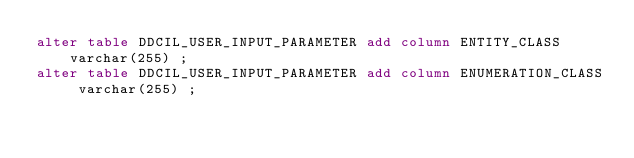Convert code to text. <code><loc_0><loc_0><loc_500><loc_500><_SQL_>alter table DDCIL_USER_INPUT_PARAMETER add column ENTITY_CLASS varchar(255) ;
alter table DDCIL_USER_INPUT_PARAMETER add column ENUMERATION_CLASS varchar(255) ;
</code> 